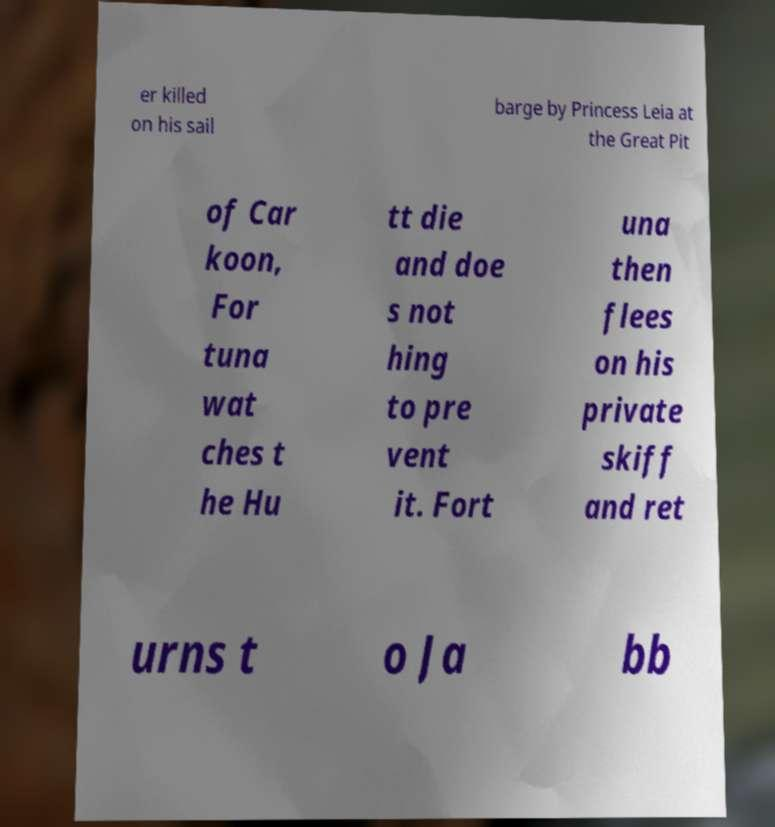Could you assist in decoding the text presented in this image and type it out clearly? er killed on his sail barge by Princess Leia at the Great Pit of Car koon, For tuna wat ches t he Hu tt die and doe s not hing to pre vent it. Fort una then flees on his private skiff and ret urns t o Ja bb 